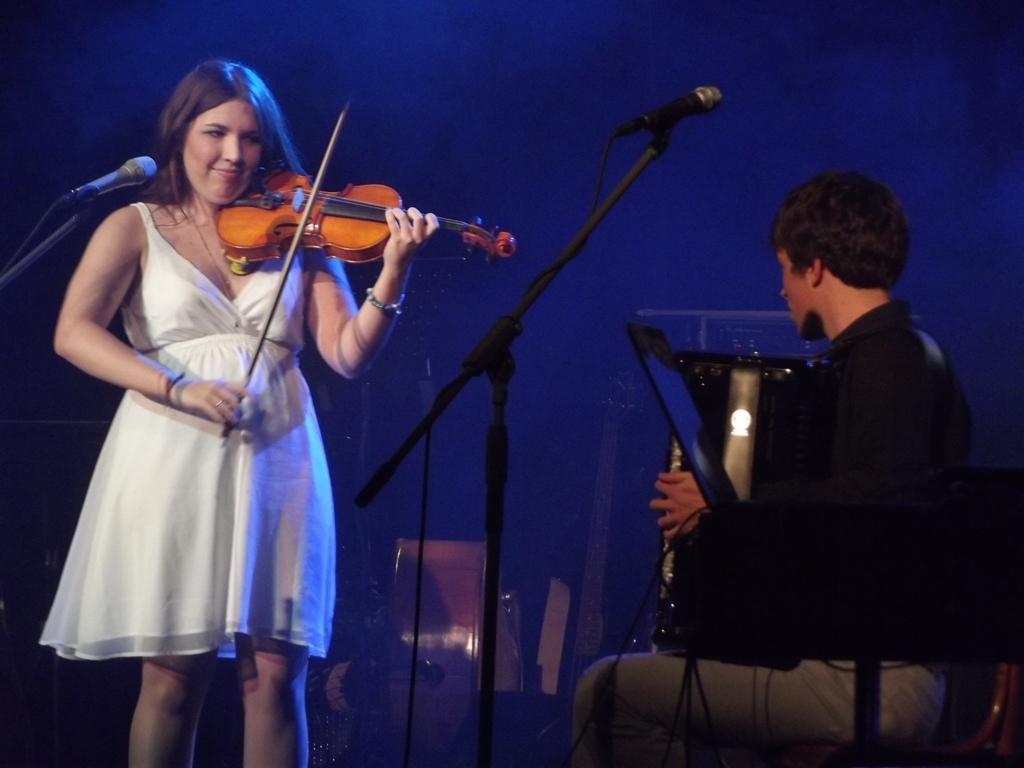What is the woman in the image doing? The woman is playing a musical instrument in the image. Can you describe the man in the image? There is a man in the image, but no specific details about him are provided. How many microphones are visible in the image? There are two microphones in the image. What grade does the woman receive for her performance on the horn in the image? There is no horn present in the image, and no performance is being evaluated, so it is not possible to determine a grade. 